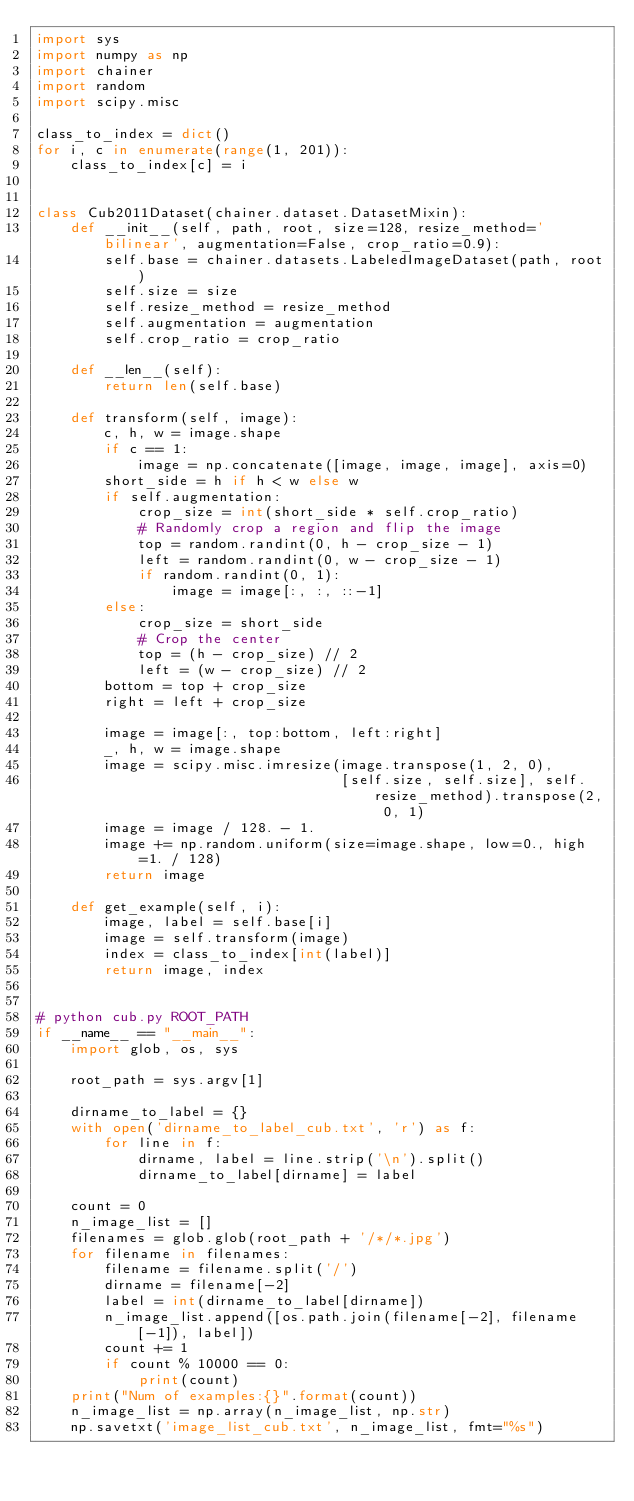Convert code to text. <code><loc_0><loc_0><loc_500><loc_500><_Python_>import sys
import numpy as np
import chainer
import random
import scipy.misc

class_to_index = dict()
for i, c in enumerate(range(1, 201)):
    class_to_index[c] = i


class Cub2011Dataset(chainer.dataset.DatasetMixin):
    def __init__(self, path, root, size=128, resize_method='bilinear', augmentation=False, crop_ratio=0.9):
        self.base = chainer.datasets.LabeledImageDataset(path, root)
        self.size = size
        self.resize_method = resize_method
        self.augmentation = augmentation
        self.crop_ratio = crop_ratio

    def __len__(self):
        return len(self.base)

    def transform(self, image):
        c, h, w = image.shape
        if c == 1:
            image = np.concatenate([image, image, image], axis=0)
        short_side = h if h < w else w
        if self.augmentation:
            crop_size = int(short_side * self.crop_ratio)
            # Randomly crop a region and flip the image
            top = random.randint(0, h - crop_size - 1)
            left = random.randint(0, w - crop_size - 1)
            if random.randint(0, 1):
                image = image[:, :, ::-1]
        else:
            crop_size = short_side
            # Crop the center
            top = (h - crop_size) // 2
            left = (w - crop_size) // 2
        bottom = top + crop_size
        right = left + crop_size

        image = image[:, top:bottom, left:right]
        _, h, w = image.shape
        image = scipy.misc.imresize(image.transpose(1, 2, 0),
                                    [self.size, self.size], self.resize_method).transpose(2, 0, 1)
        image = image / 128. - 1.
        image += np.random.uniform(size=image.shape, low=0., high=1. / 128)
        return image

    def get_example(self, i):
        image, label = self.base[i]
        image = self.transform(image)
        index = class_to_index[int(label)]
        return image, index


# python cub.py ROOT_PATH
if __name__ == "__main__":
    import glob, os, sys

    root_path = sys.argv[1]

    dirname_to_label = {}
    with open('dirname_to_label_cub.txt', 'r') as f:
        for line in f:
            dirname, label = line.strip('\n').split()
            dirname_to_label[dirname] = label

    count = 0
    n_image_list = []
    filenames = glob.glob(root_path + '/*/*.jpg')
    for filename in filenames:
        filename = filename.split('/')
        dirname = filename[-2]
        label = int(dirname_to_label[dirname])
        n_image_list.append([os.path.join(filename[-2], filename[-1]), label])
        count += 1
        if count % 10000 == 0:
            print(count)
    print("Num of examples:{}".format(count))
    n_image_list = np.array(n_image_list, np.str)
    np.savetxt('image_list_cub.txt', n_image_list, fmt="%s")
</code> 